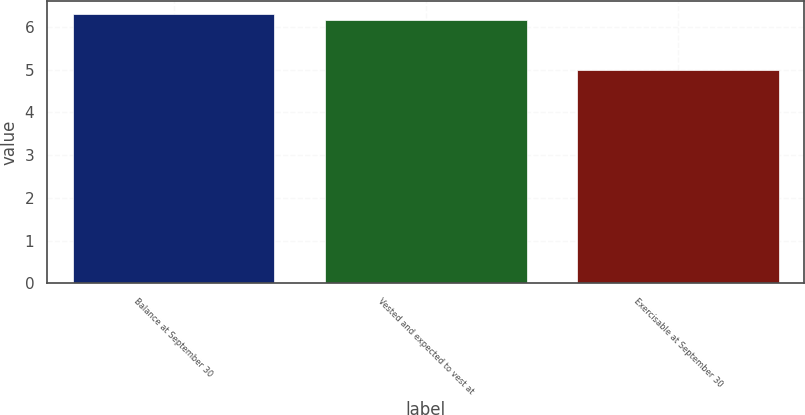<chart> <loc_0><loc_0><loc_500><loc_500><bar_chart><fcel>Balance at September 30<fcel>Vested and expected to vest at<fcel>Exercisable at September 30<nl><fcel>6.29<fcel>6.16<fcel>4.98<nl></chart> 